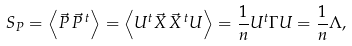<formula> <loc_0><loc_0><loc_500><loc_500>S _ { P } = \left < \vec { P } \, \vec { P } ^ { \, t } \right > = \left < U ^ { t } \vec { X } \, \vec { X } ^ { \, t } U \right > = \frac { 1 } { n } U ^ { t } \Gamma U = \frac { 1 } { n } \Lambda ,</formula> 